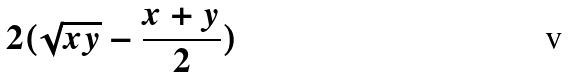<formula> <loc_0><loc_0><loc_500><loc_500>2 ( \sqrt { x y } - \frac { x + y } { 2 } )</formula> 